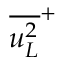Convert formula to latex. <formula><loc_0><loc_0><loc_500><loc_500>{ \overline { { u _ { L } ^ { 2 } } } } ^ { + }</formula> 